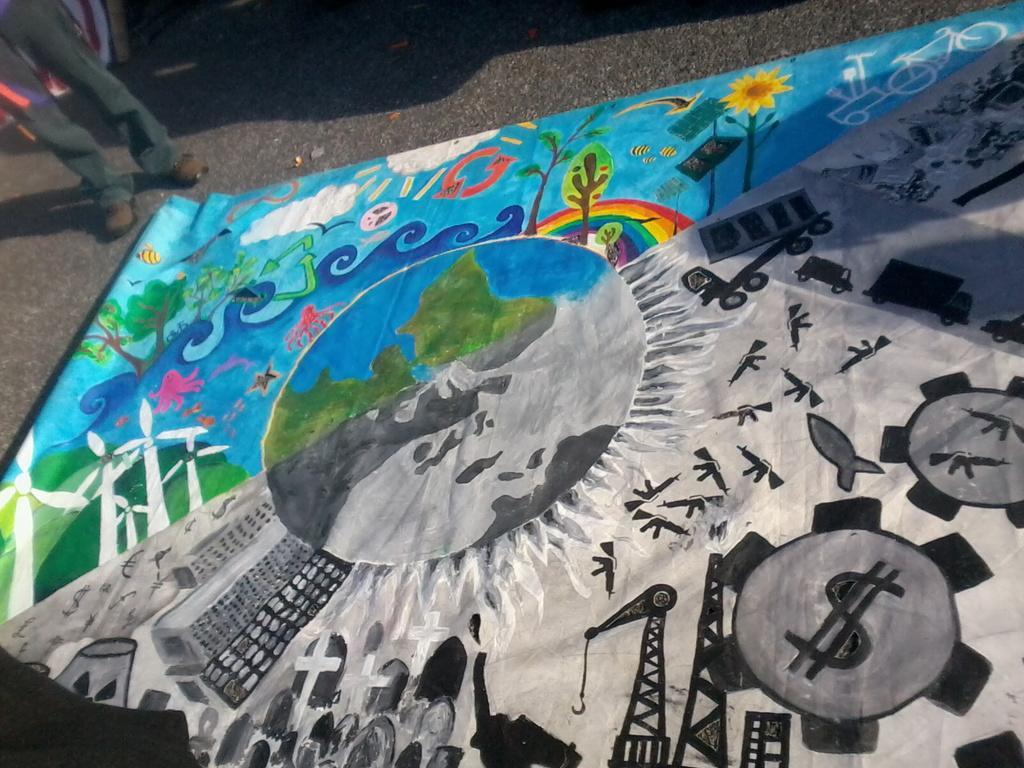Please provide a concise description of this image. In this picture we can see painting, some objects and a person's legs on the road. 